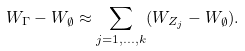Convert formula to latex. <formula><loc_0><loc_0><loc_500><loc_500>W _ { \Gamma } - W _ { \emptyset } \approx \sum _ { j = 1 , \dots , k } ( W _ { Z _ { j } } - W _ { \emptyset } ) .</formula> 